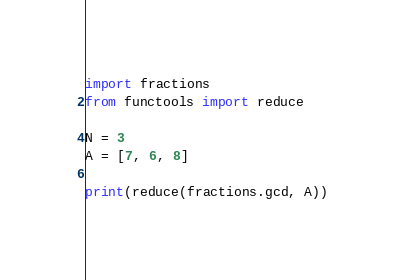Convert code to text. <code><loc_0><loc_0><loc_500><loc_500><_Python_>import fractions
from functools import reduce

N = 3
A = [7, 6, 8]

print(reduce(fractions.gcd, A))</code> 